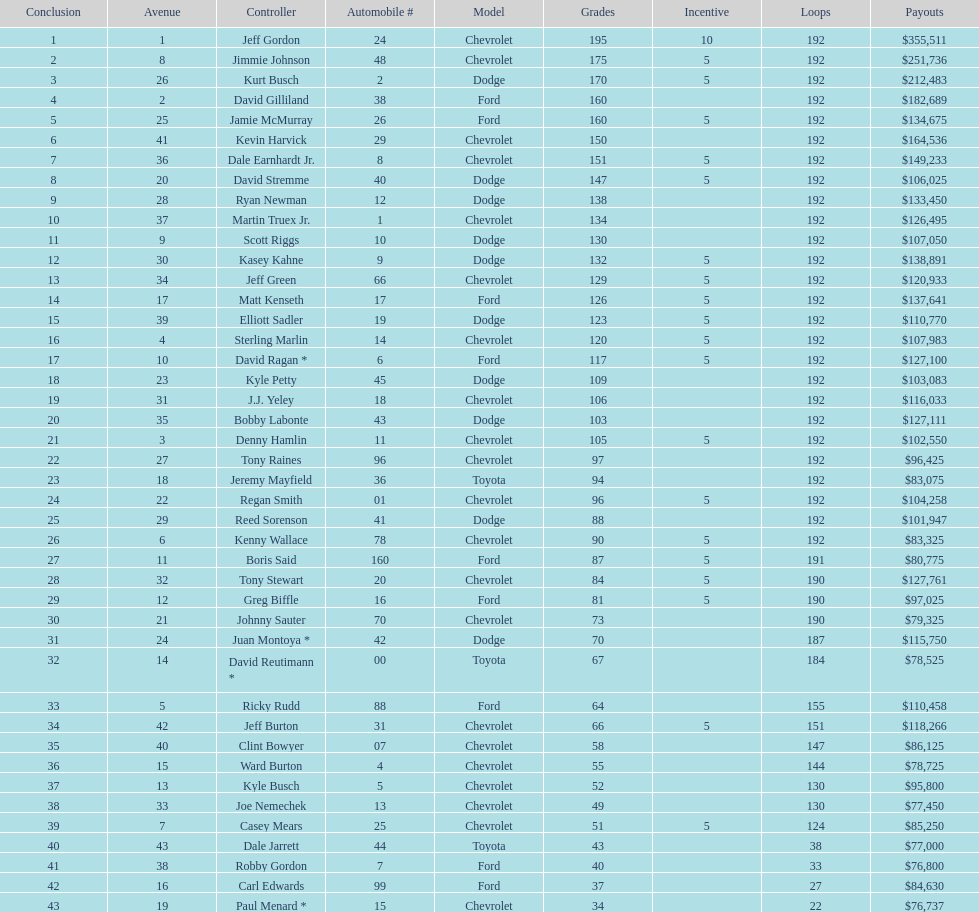What make did kurt busch drive? Dodge. 